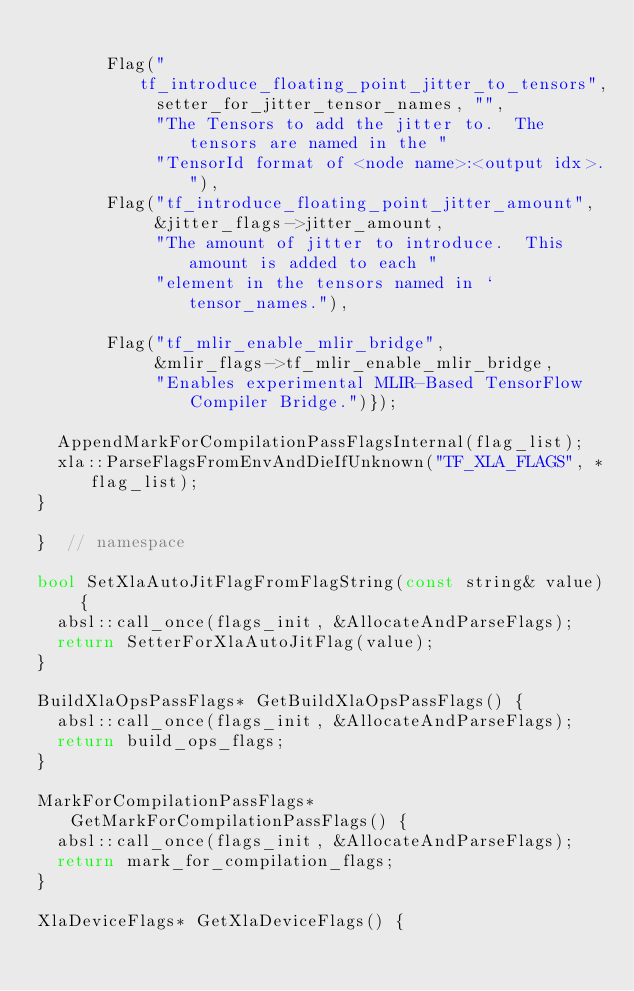<code> <loc_0><loc_0><loc_500><loc_500><_C++_>
       Flag("tf_introduce_floating_point_jitter_to_tensors",
            setter_for_jitter_tensor_names, "",
            "The Tensors to add the jitter to.  The tensors are named in the "
            "TensorId format of <node name>:<output idx>."),
       Flag("tf_introduce_floating_point_jitter_amount",
            &jitter_flags->jitter_amount,
            "The amount of jitter to introduce.  This amount is added to each "
            "element in the tensors named in `tensor_names."),

       Flag("tf_mlir_enable_mlir_bridge",
            &mlir_flags->tf_mlir_enable_mlir_bridge,
            "Enables experimental MLIR-Based TensorFlow Compiler Bridge.")});

  AppendMarkForCompilationPassFlagsInternal(flag_list);
  xla::ParseFlagsFromEnvAndDieIfUnknown("TF_XLA_FLAGS", *flag_list);
}

}  // namespace

bool SetXlaAutoJitFlagFromFlagString(const string& value) {
  absl::call_once(flags_init, &AllocateAndParseFlags);
  return SetterForXlaAutoJitFlag(value);
}

BuildXlaOpsPassFlags* GetBuildXlaOpsPassFlags() {
  absl::call_once(flags_init, &AllocateAndParseFlags);
  return build_ops_flags;
}

MarkForCompilationPassFlags* GetMarkForCompilationPassFlags() {
  absl::call_once(flags_init, &AllocateAndParseFlags);
  return mark_for_compilation_flags;
}

XlaDeviceFlags* GetXlaDeviceFlags() {</code> 